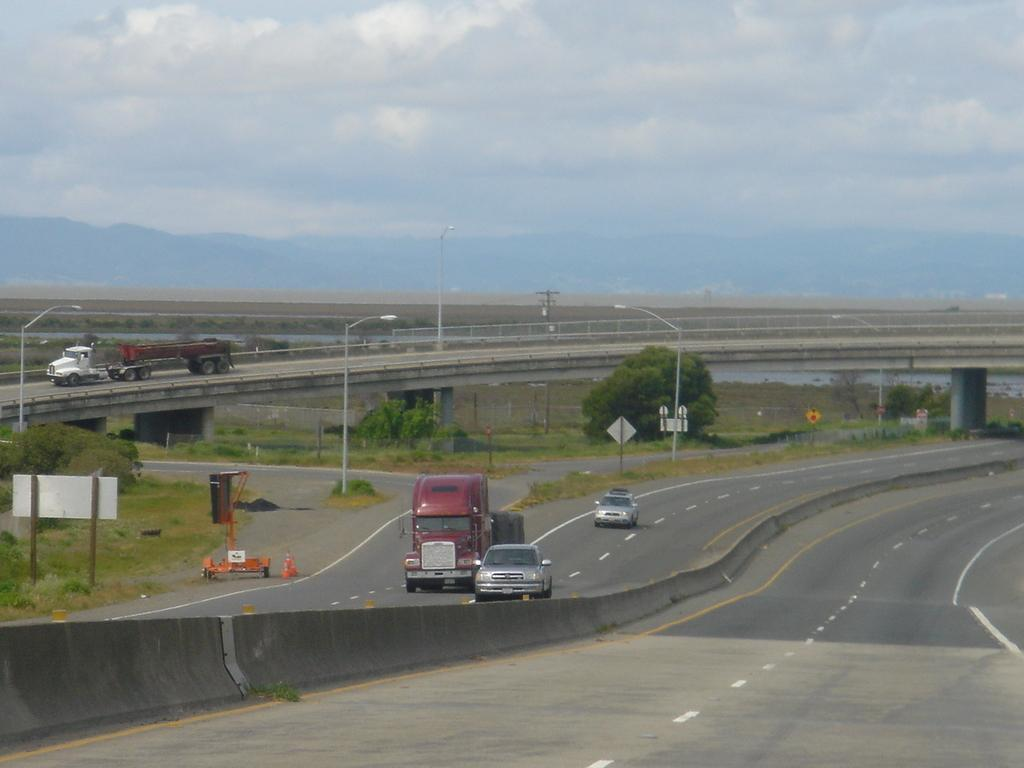What can be seen on the road in the image? There are vehicles on the road in the image. What type of natural elements are visible in the image? There are trees visible in the image. What structures can be seen in the image? There are poles and a bridge in the image. What is visible in the background of the image? There are hills and the sky visible in the background of the image. Where are the flowers located in the image? There are no flowers visible in the image. What type of bed is present in the middle of the image? There is no bed present in the image. 